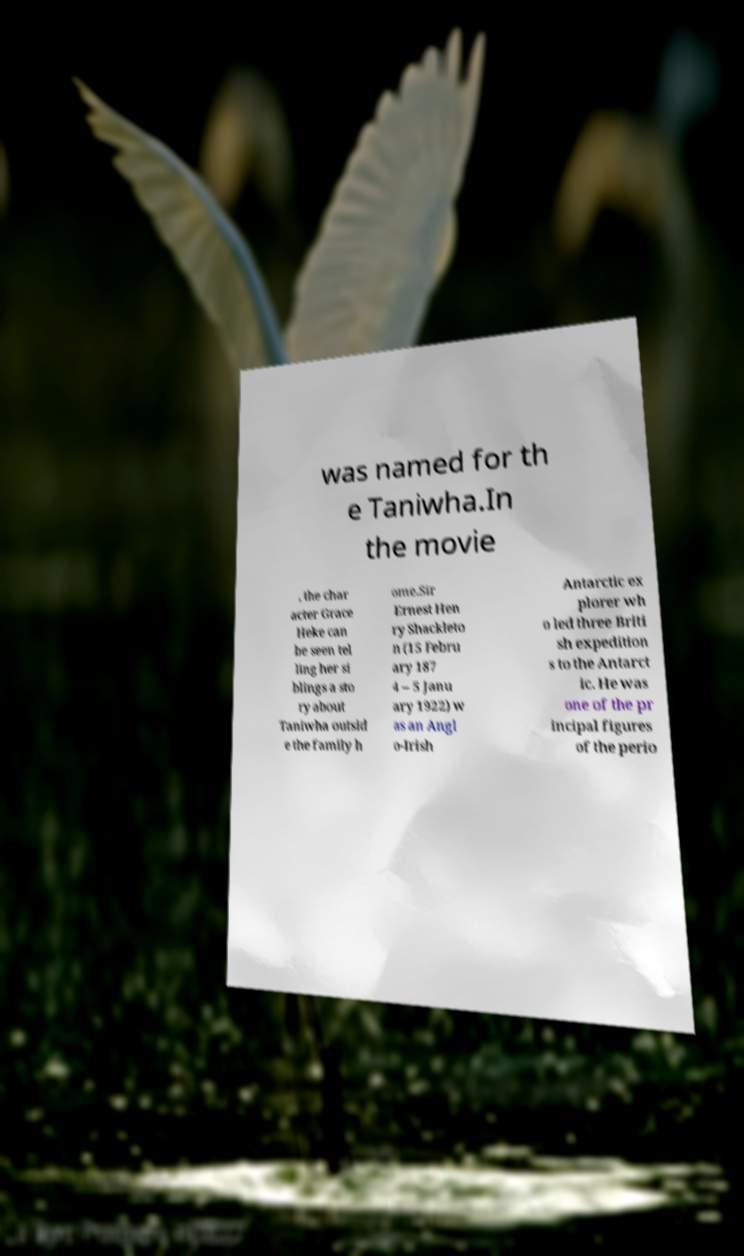Please identify and transcribe the text found in this image. was named for th e Taniwha.In the movie , the char acter Grace Heke can be seen tel ling her si blings a sto ry about Taniwha outsid e the family h ome.Sir Ernest Hen ry Shackleto n (15 Febru ary 187 4 – 5 Janu ary 1922) w as an Angl o-Irish Antarctic ex plorer wh o led three Briti sh expedition s to the Antarct ic. He was one of the pr incipal figures of the perio 